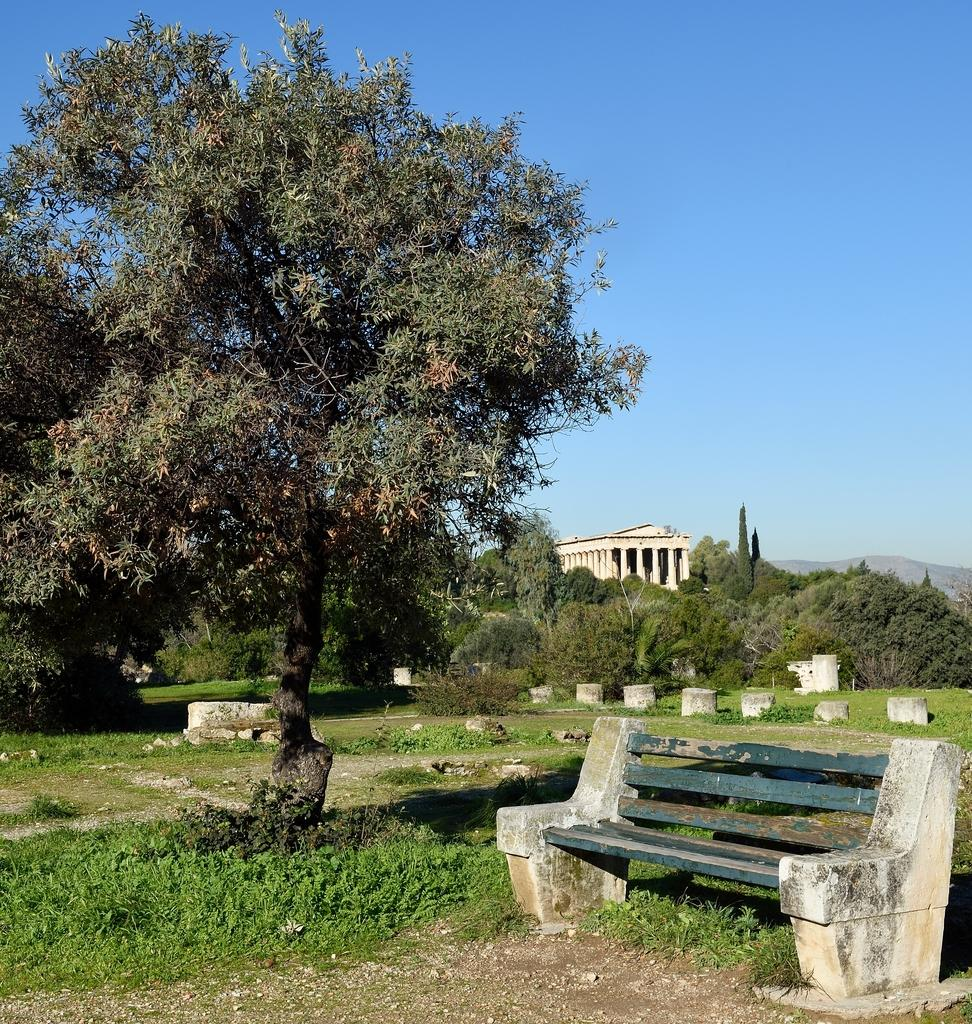What is located on the left side of the image? There is a bench on the left side of the image. What type of vegetation can be seen in the image? There are plants in the image. What can be seen on the ground in the image? There are stones on a path in the image. What is visible in the background of the image? There are trees and a building in the background of the image. Can you see any toes or boots in the image? There are no toes or boots present in the image. Is there a flame visible in the image? There is no flame present in the image. 